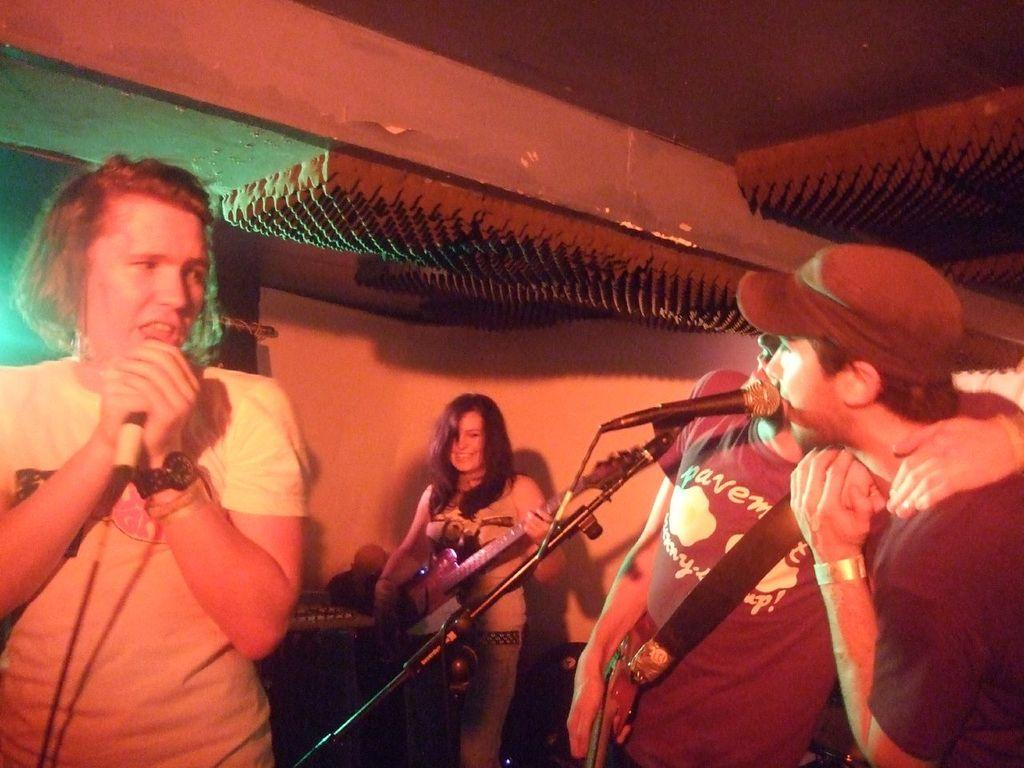How many people are in the image? There are three persons in the image. What are the three persons doing in the image? The three persons are standing at mics and singing. Can you describe the background of the image? There is a woman in the background of the image. What is the woman holding in the image? The woman is holding a guitar. What is the woman doing with the guitar? The woman is playing the guitar. What type of star can be seen in the image? There is no star visible in the image; it features three persons singing and a woman playing a guitar in the background. 